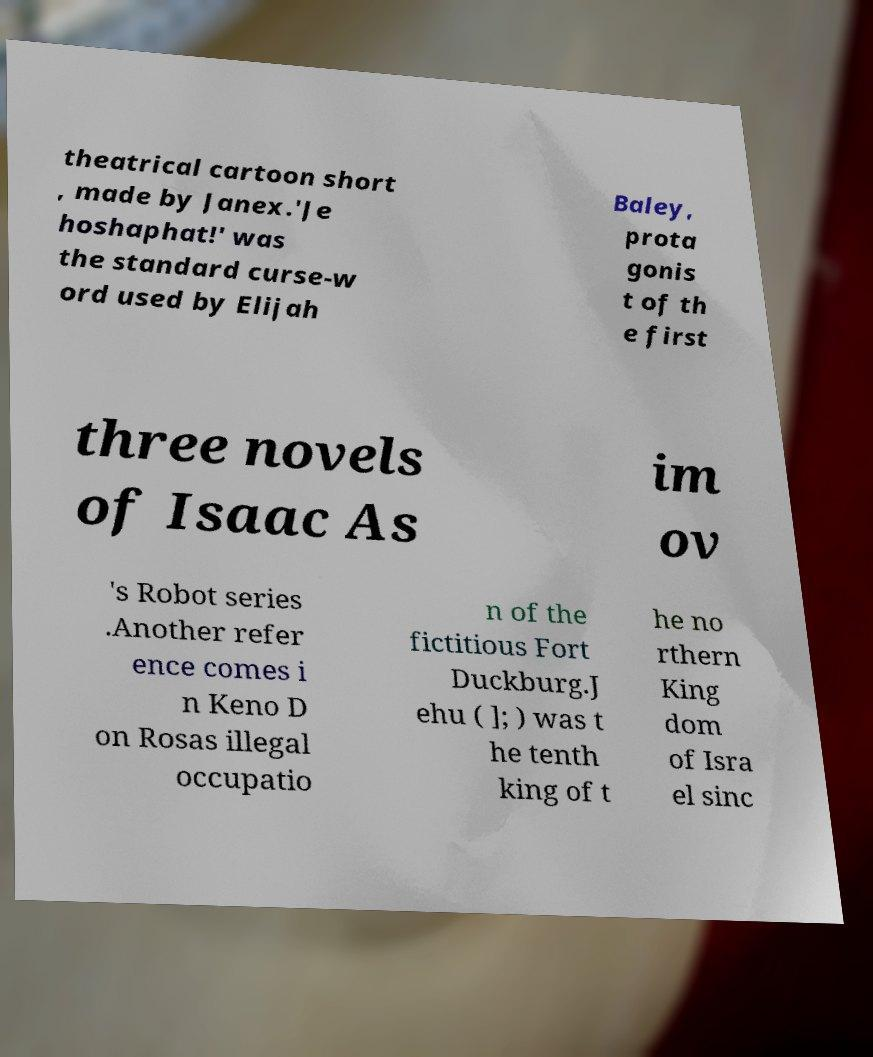Please identify and transcribe the text found in this image. theatrical cartoon short , made by Janex.'Je hoshaphat!' was the standard curse-w ord used by Elijah Baley, prota gonis t of th e first three novels of Isaac As im ov 's Robot series .Another refer ence comes i n Keno D on Rosas illegal occupatio n of the fictitious Fort Duckburg.J ehu ( ]; ) was t he tenth king of t he no rthern King dom of Isra el sinc 